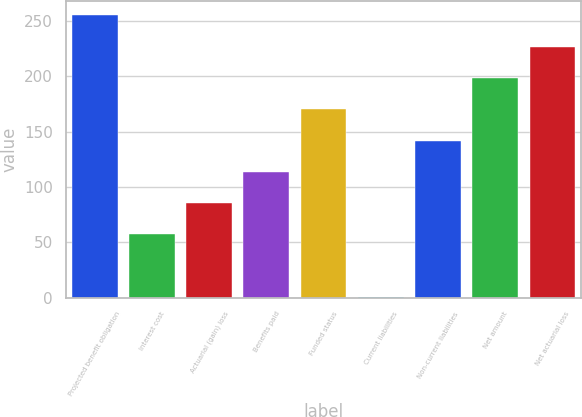Convert chart. <chart><loc_0><loc_0><loc_500><loc_500><bar_chart><fcel>Projected benefit obligation<fcel>Interest cost<fcel>Actuarial (gain) loss<fcel>Benefits paid<fcel>Funded status<fcel>Current liabilities<fcel>Non-current liabilities<fcel>Net amount<fcel>Net actuarial loss<nl><fcel>255.02<fcel>57.06<fcel>85.34<fcel>113.62<fcel>170.18<fcel>0.5<fcel>141.9<fcel>198.46<fcel>226.74<nl></chart> 